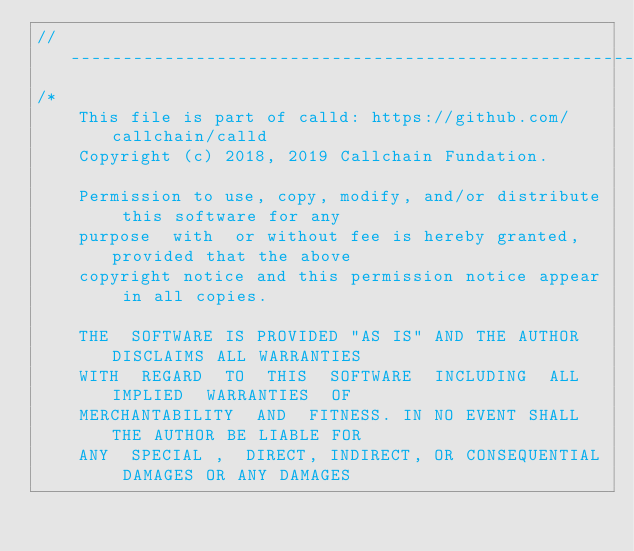<code> <loc_0><loc_0><loc_500><loc_500><_C++_>//------------------------------------------------------------------------------
/*
    This file is part of calld: https://github.com/callchain/calld
    Copyright (c) 2018, 2019 Callchain Fundation.

    Permission to use, copy, modify, and/or distribute this software for any
    purpose  with  or without fee is hereby granted, provided that the above
    copyright notice and this permission notice appear in all copies.

    THE  SOFTWARE IS PROVIDED "AS IS" AND THE AUTHOR DISCLAIMS ALL WARRANTIES
    WITH  REGARD  TO  THIS  SOFTWARE  INCLUDING  ALL  IMPLIED  WARRANTIES  OF
    MERCHANTABILITY  AND  FITNESS. IN NO EVENT SHALL THE AUTHOR BE LIABLE FOR
    ANY  SPECIAL ,  DIRECT, INDIRECT, OR CONSEQUENTIAL DAMAGES OR ANY DAMAGES</code> 